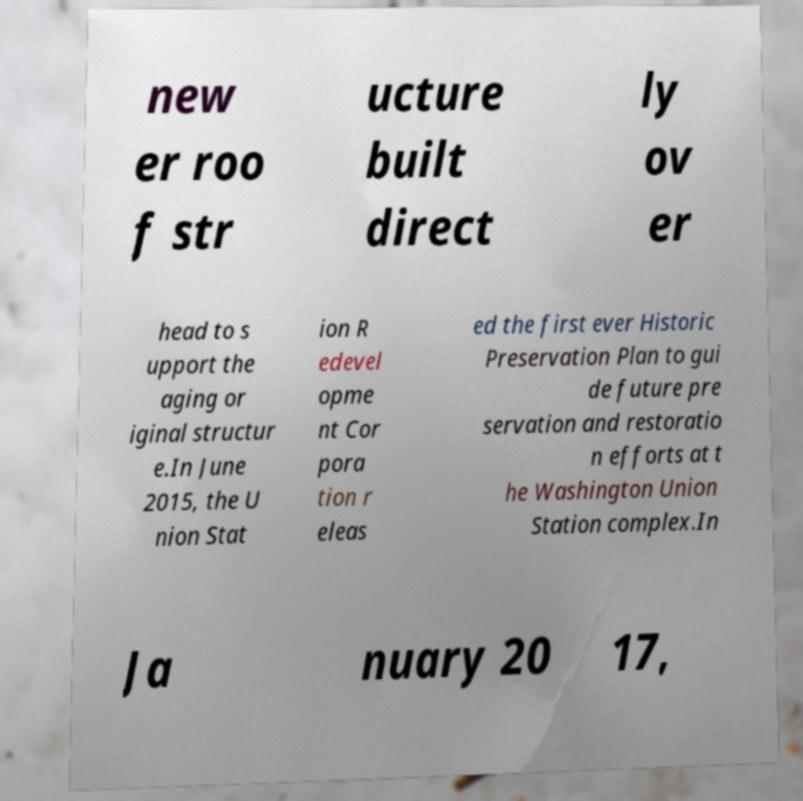What messages or text are displayed in this image? I need them in a readable, typed format. new er roo f str ucture built direct ly ov er head to s upport the aging or iginal structur e.In June 2015, the U nion Stat ion R edevel opme nt Cor pora tion r eleas ed the first ever Historic Preservation Plan to gui de future pre servation and restoratio n efforts at t he Washington Union Station complex.In Ja nuary 20 17, 